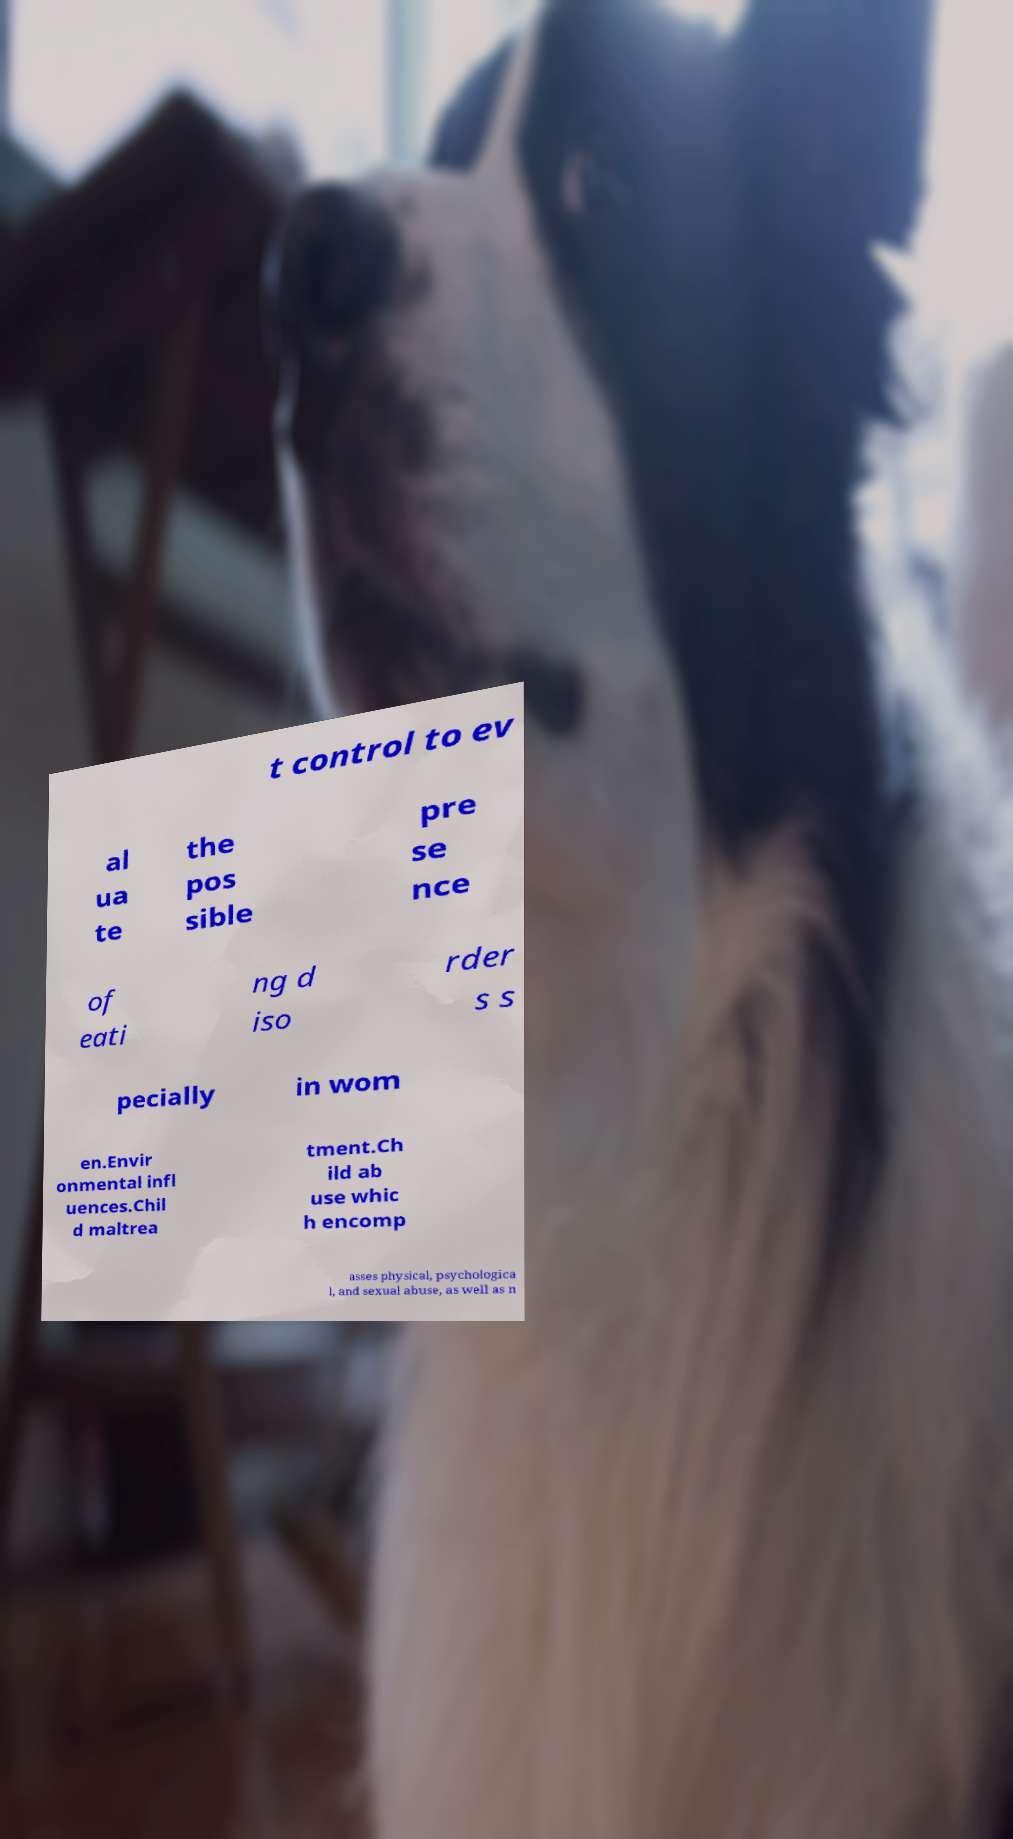I need the written content from this picture converted into text. Can you do that? t control to ev al ua te the pos sible pre se nce of eati ng d iso rder s s pecially in wom en.Envir onmental infl uences.Chil d maltrea tment.Ch ild ab use whic h encomp asses physical, psychologica l, and sexual abuse, as well as n 